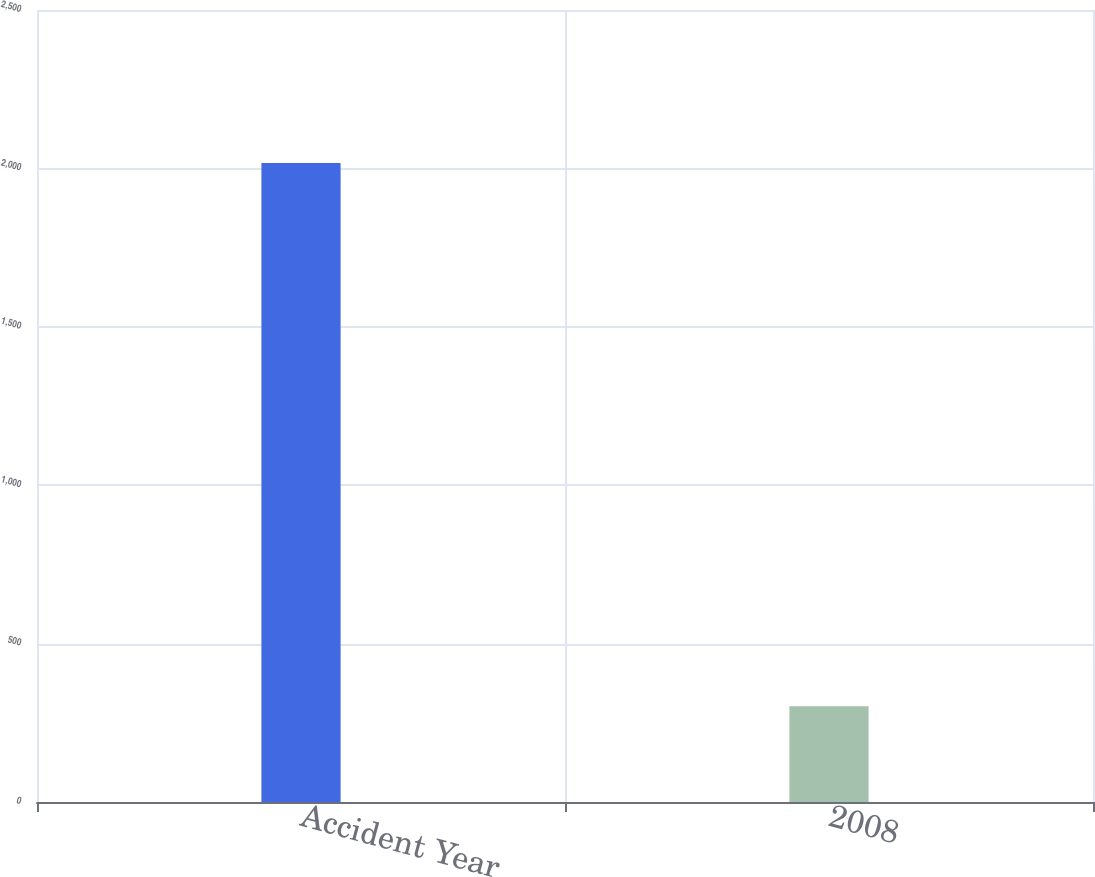<chart> <loc_0><loc_0><loc_500><loc_500><bar_chart><fcel>Accident Year<fcel>2008<nl><fcel>2017<fcel>302<nl></chart> 